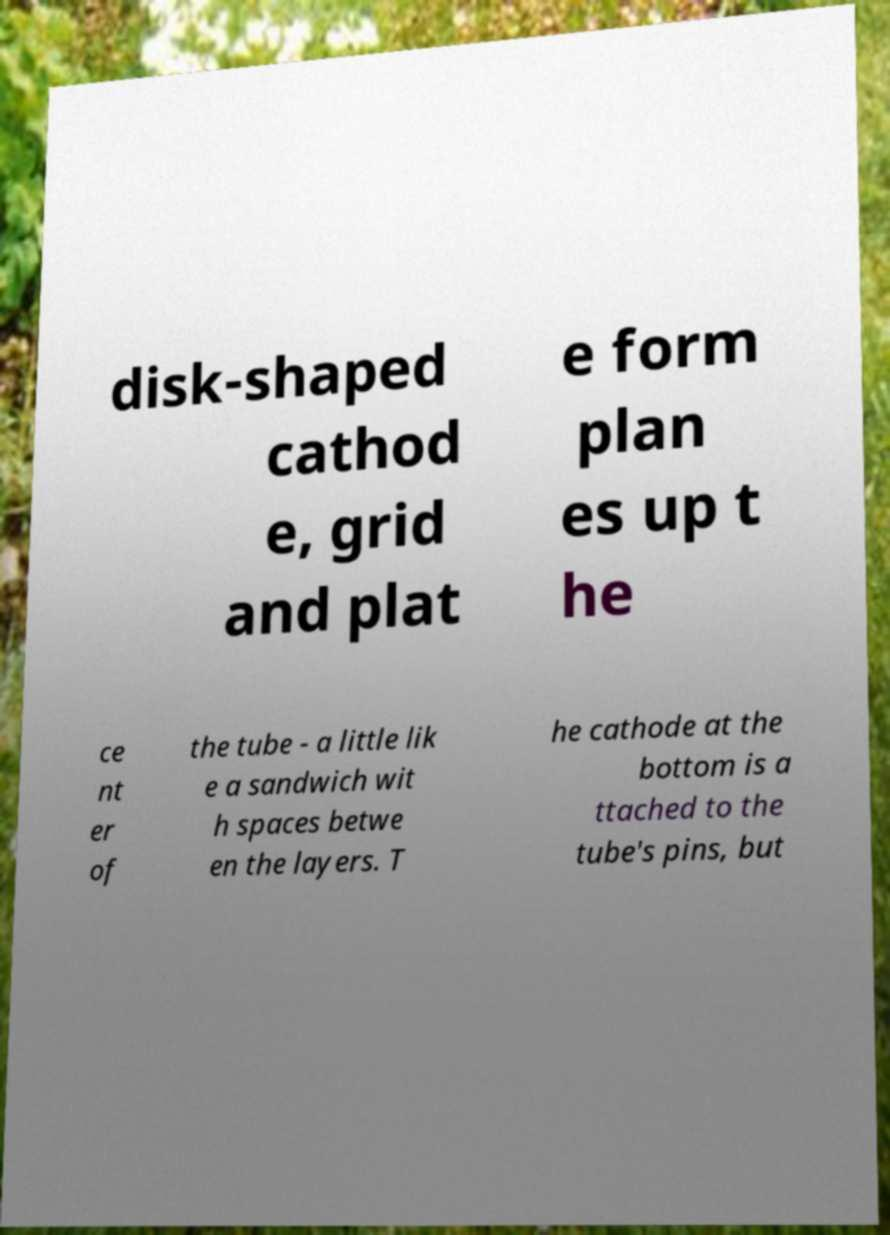Could you extract and type out the text from this image? disk-shaped cathod e, grid and plat e form plan es up t he ce nt er of the tube - a little lik e a sandwich wit h spaces betwe en the layers. T he cathode at the bottom is a ttached to the tube's pins, but 